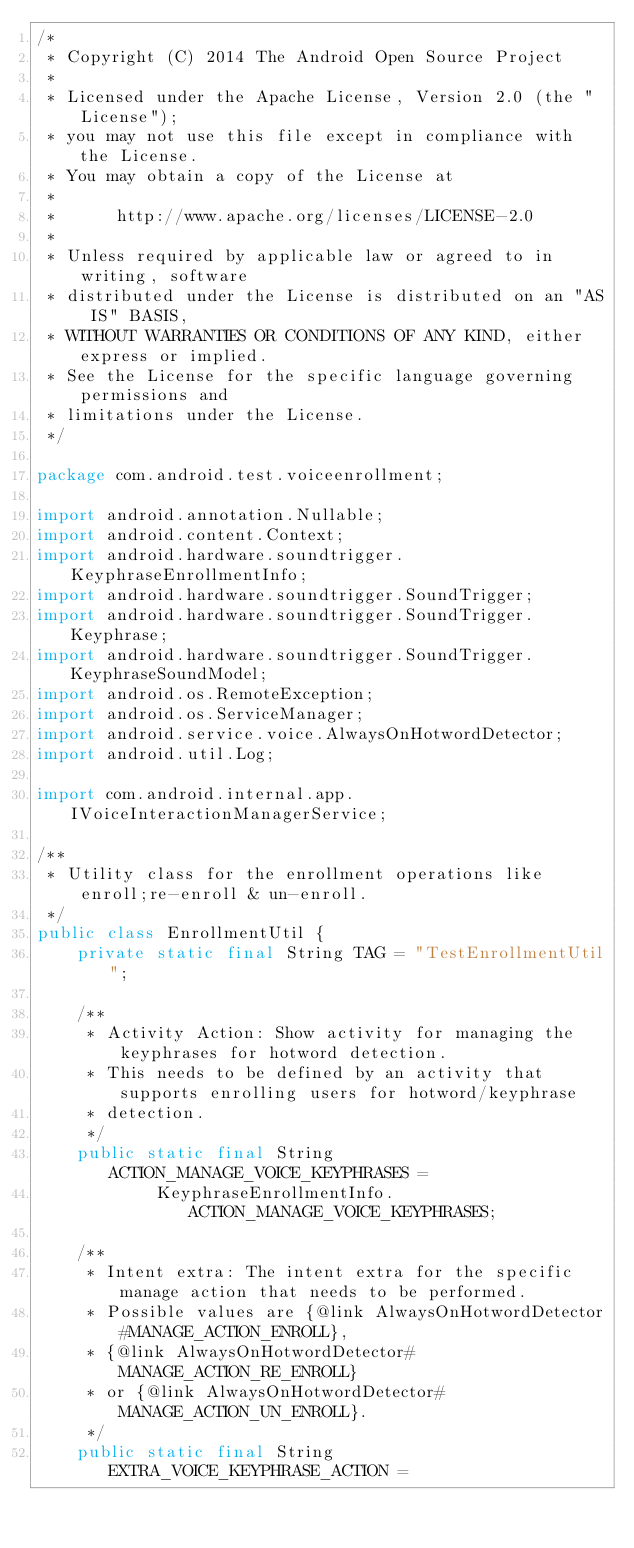Convert code to text. <code><loc_0><loc_0><loc_500><loc_500><_Java_>/*
 * Copyright (C) 2014 The Android Open Source Project
 *
 * Licensed under the Apache License, Version 2.0 (the "License");
 * you may not use this file except in compliance with the License.
 * You may obtain a copy of the License at
 *
 *      http://www.apache.org/licenses/LICENSE-2.0
 *
 * Unless required by applicable law or agreed to in writing, software
 * distributed under the License is distributed on an "AS IS" BASIS,
 * WITHOUT WARRANTIES OR CONDITIONS OF ANY KIND, either express or implied.
 * See the License for the specific language governing permissions and
 * limitations under the License.
 */

package com.android.test.voiceenrollment;

import android.annotation.Nullable;
import android.content.Context;
import android.hardware.soundtrigger.KeyphraseEnrollmentInfo;
import android.hardware.soundtrigger.SoundTrigger;
import android.hardware.soundtrigger.SoundTrigger.Keyphrase;
import android.hardware.soundtrigger.SoundTrigger.KeyphraseSoundModel;
import android.os.RemoteException;
import android.os.ServiceManager;
import android.service.voice.AlwaysOnHotwordDetector;
import android.util.Log;

import com.android.internal.app.IVoiceInteractionManagerService;

/**
 * Utility class for the enrollment operations like enroll;re-enroll & un-enroll.
 */
public class EnrollmentUtil {
    private static final String TAG = "TestEnrollmentUtil";

    /**
     * Activity Action: Show activity for managing the keyphrases for hotword detection.
     * This needs to be defined by an activity that supports enrolling users for hotword/keyphrase
     * detection.
     */
    public static final String ACTION_MANAGE_VOICE_KEYPHRASES =
            KeyphraseEnrollmentInfo.ACTION_MANAGE_VOICE_KEYPHRASES;

    /**
     * Intent extra: The intent extra for the specific manage action that needs to be performed.
     * Possible values are {@link AlwaysOnHotwordDetector#MANAGE_ACTION_ENROLL},
     * {@link AlwaysOnHotwordDetector#MANAGE_ACTION_RE_ENROLL}
     * or {@link AlwaysOnHotwordDetector#MANAGE_ACTION_UN_ENROLL}.
     */
    public static final String EXTRA_VOICE_KEYPHRASE_ACTION =</code> 